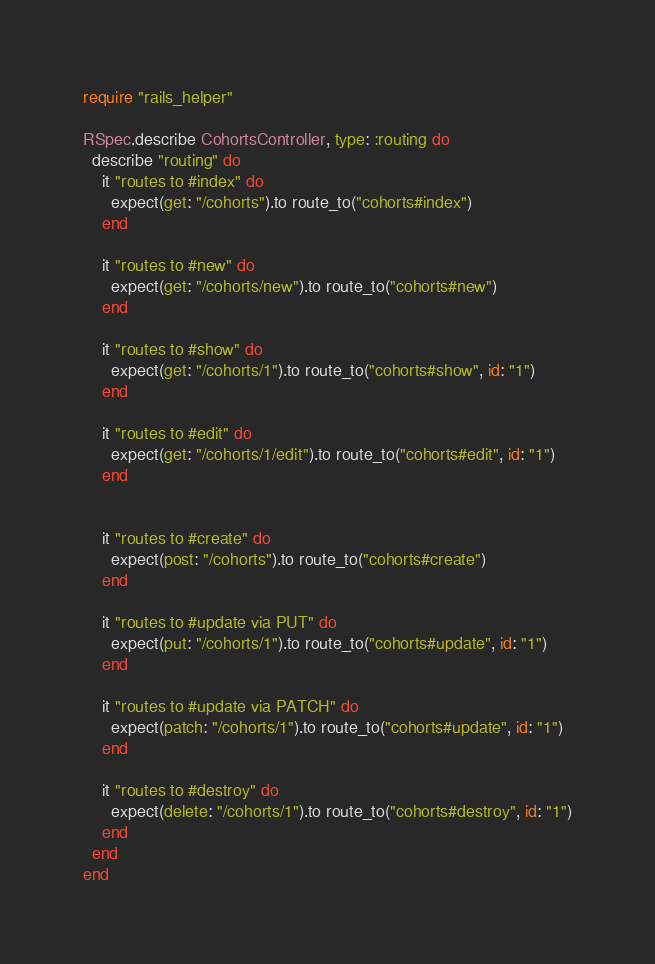<code> <loc_0><loc_0><loc_500><loc_500><_Ruby_>require "rails_helper"

RSpec.describe CohortsController, type: :routing do
  describe "routing" do
    it "routes to #index" do
      expect(get: "/cohorts").to route_to("cohorts#index")
    end

    it "routes to #new" do
      expect(get: "/cohorts/new").to route_to("cohorts#new")
    end

    it "routes to #show" do
      expect(get: "/cohorts/1").to route_to("cohorts#show", id: "1")
    end

    it "routes to #edit" do
      expect(get: "/cohorts/1/edit").to route_to("cohorts#edit", id: "1")
    end


    it "routes to #create" do
      expect(post: "/cohorts").to route_to("cohorts#create")
    end

    it "routes to #update via PUT" do
      expect(put: "/cohorts/1").to route_to("cohorts#update", id: "1")
    end

    it "routes to #update via PATCH" do
      expect(patch: "/cohorts/1").to route_to("cohorts#update", id: "1")
    end

    it "routes to #destroy" do
      expect(delete: "/cohorts/1").to route_to("cohorts#destroy", id: "1")
    end
  end
end
</code> 